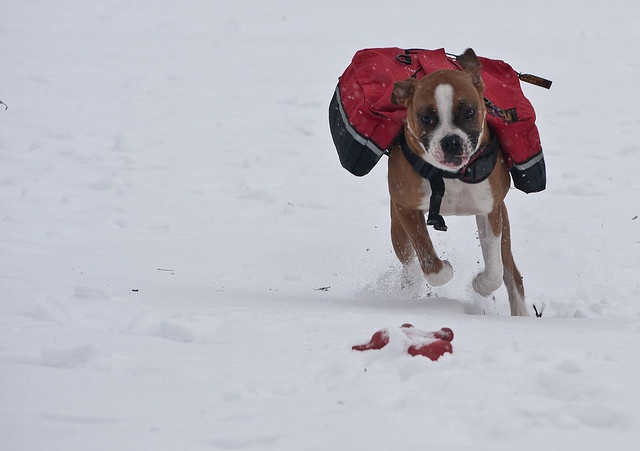Describe the objects in this image and their specific colors. I can see backpack in lightgray, black, maroon, and brown tones and dog in lightgray, darkgray, black, gray, and maroon tones in this image. 